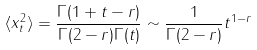Convert formula to latex. <formula><loc_0><loc_0><loc_500><loc_500>\langle x _ { t } ^ { 2 } \rangle = \frac { \Gamma ( 1 + t - r ) } { \Gamma ( 2 - r ) \Gamma ( t ) } \sim \frac { 1 } { \Gamma ( 2 - r ) } t ^ { 1 - r }</formula> 